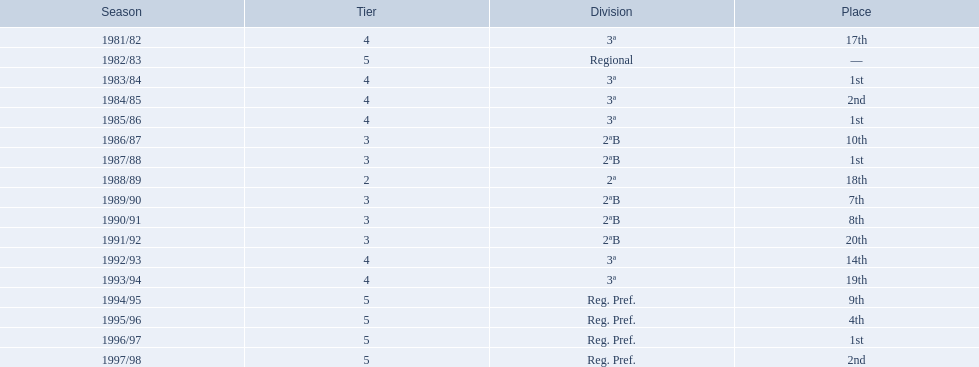During which years did the team have a season? 1981/82, 1982/83, 1983/84, 1984/85, 1985/86, 1986/87, 1987/88, 1988/89, 1989/90, 1990/91, 1991/92, 1992/93, 1993/94, 1994/95, 1995/96, 1996/97, 1997/98. In which of those years did they not make it to the top 10? 1981/82, 1988/89, 1991/92, 1992/93, 1993/94. In those years, when was their worst performance? 1991/92. 